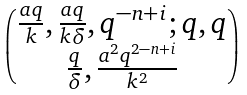<formula> <loc_0><loc_0><loc_500><loc_500>\begin{pmatrix} \frac { a q } { k } , \frac { a q } { k \delta } , q ^ { - n + i } ; q , q \\ \frac { q } { \delta } , \frac { a ^ { 2 } q ^ { 2 - n + i } } { k ^ { 2 } } \end{pmatrix}</formula> 